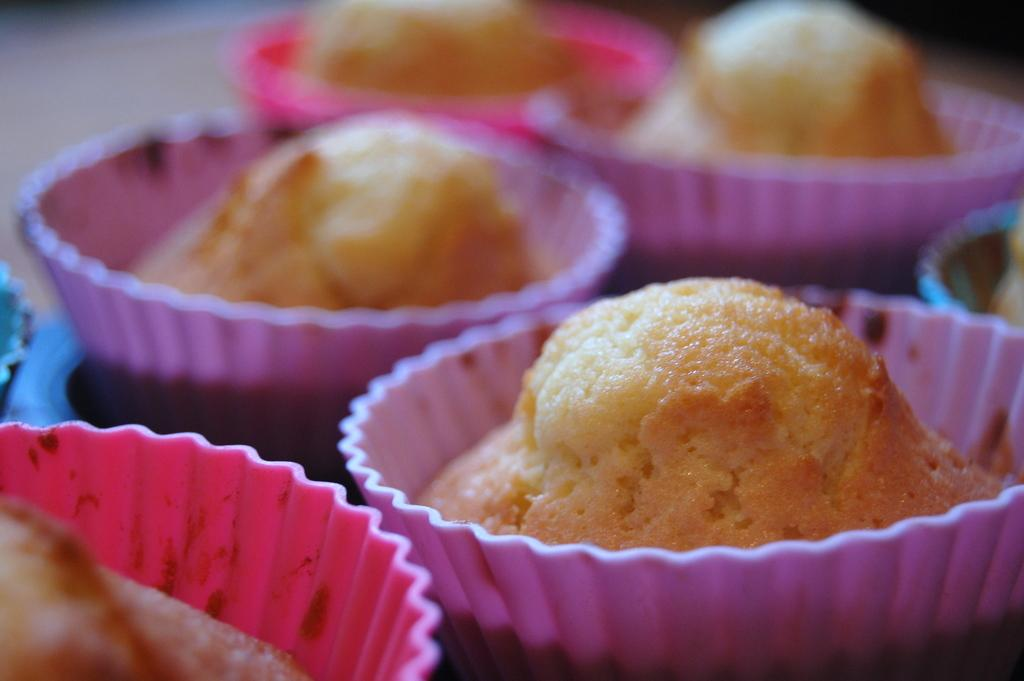What type of containers are visible in the image? There are cups in the image. What color are the cups? The cups are pink in color. What is inside the cups? There are cupcakes in the cups. What colors are the cupcakes? The cupcakes are cream and brown in color. What type of honey is dripping from the shirt in the image? There is no shirt or honey present in the image. How many hoses can be seen connected to the cups in the image? There are no hoses connected to the cups in the image. 